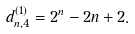<formula> <loc_0><loc_0><loc_500><loc_500>d ^ { ( 1 ) } _ { n , 4 } = 2 ^ { n } - 2 n + 2 .</formula> 